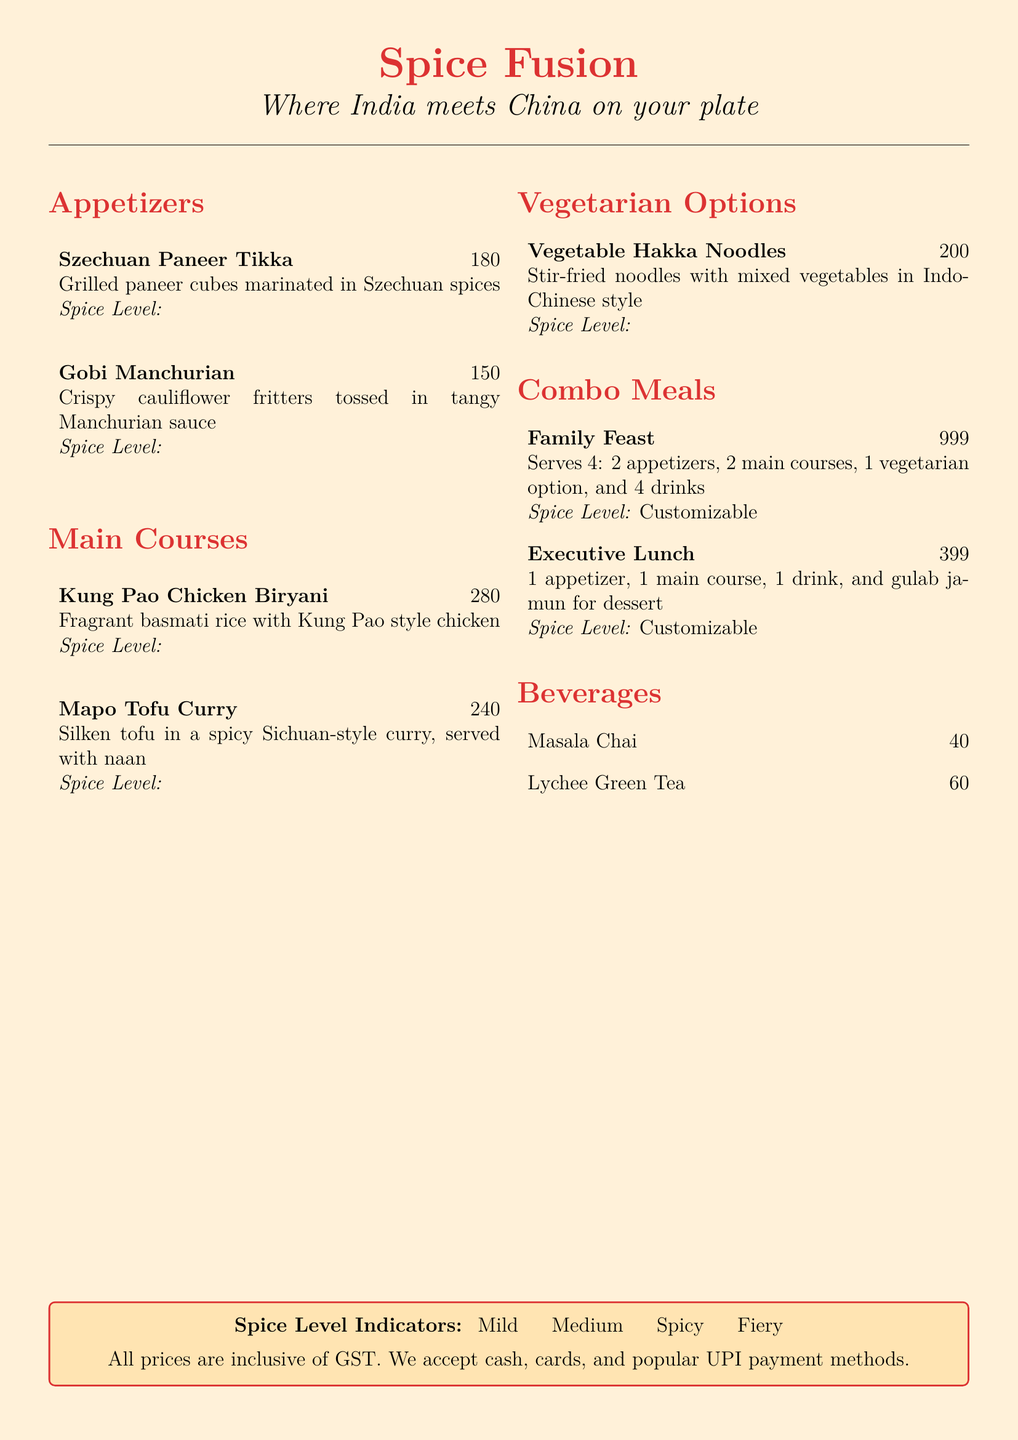What is the price of Gobi Manchurian? The price is specifically listed under the appetizers section of the menu.
Answer: ₹150 Which item has the highest spice level? The spice level indicators show that the spiciest item has four peppers.
Answer: Mapo Tofu Curry What is included in the Family Feast combo? The Family Feast combo details the components provided in the serving, which includes appetizers, main courses, vegetarian option, and drinks.
Answer: 2 appetizers, 2 main courses, 1 vegetarian option, and 4 drinks How many drinks are included in the Executive Lunch? The menu item specifies the number of drinks included in the Executive Lunch combo option.
Answer: 1 drink What type of tea is available for ₹60? The price list under beverages indicates the type of tea available at that price.
Answer: Lychee Green Tea What is the spice level for Vegetable Hakka Noodles? The spice level is indicated by a specific number of peppers mentioned next to the item in the menu.
Answer: 🌶️ Is there a dessert in the Executive Lunch combo? The description of the Executive Lunch combo explicitly mentions whether a dessert is included or not.
Answer: Yes, gulab jamun What do the spice level indicators represent? The document provides a specific section defining what each spice level symbol means.
Answer: 🌶️ Mild, 🌶️🌶️ Medium, 🌶️🌶️🌶️ Spicy, 🌶️🌶️🌶️🌶️ Fiery 